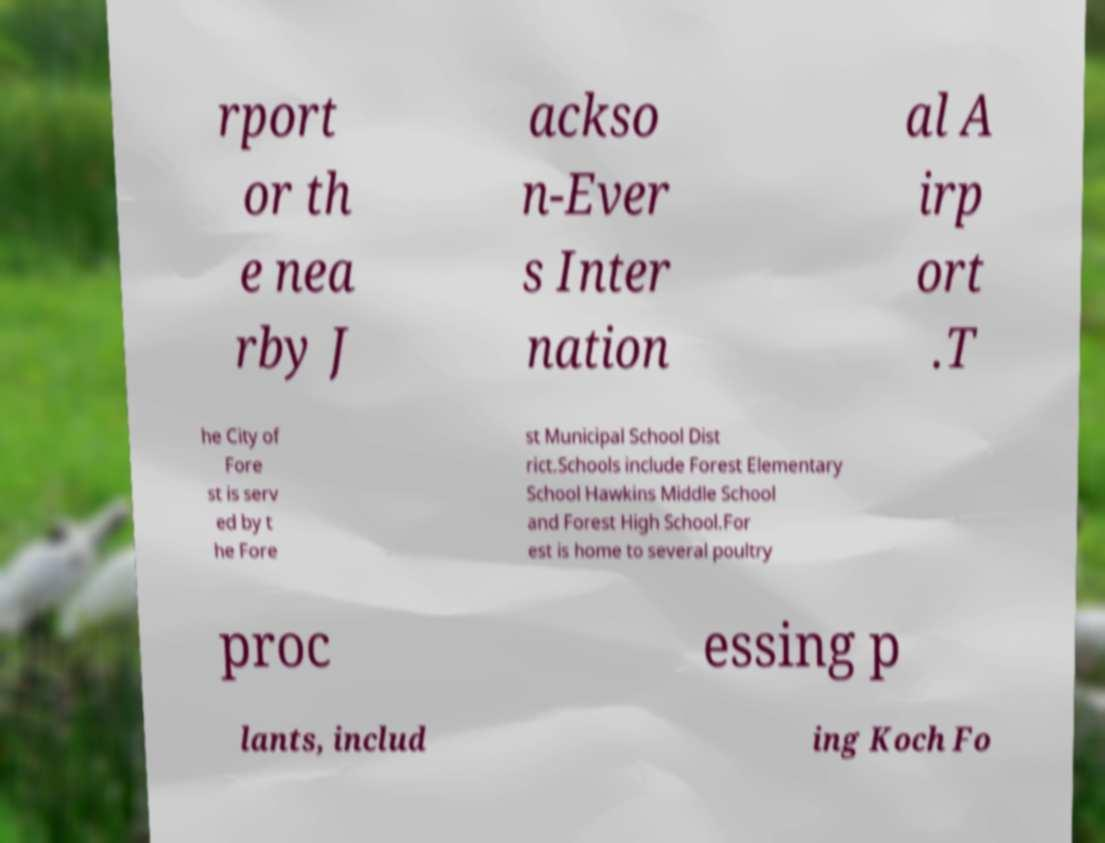There's text embedded in this image that I need extracted. Can you transcribe it verbatim? rport or th e nea rby J ackso n-Ever s Inter nation al A irp ort .T he City of Fore st is serv ed by t he Fore st Municipal School Dist rict.Schools include Forest Elementary School Hawkins Middle School and Forest High School.For est is home to several poultry proc essing p lants, includ ing Koch Fo 